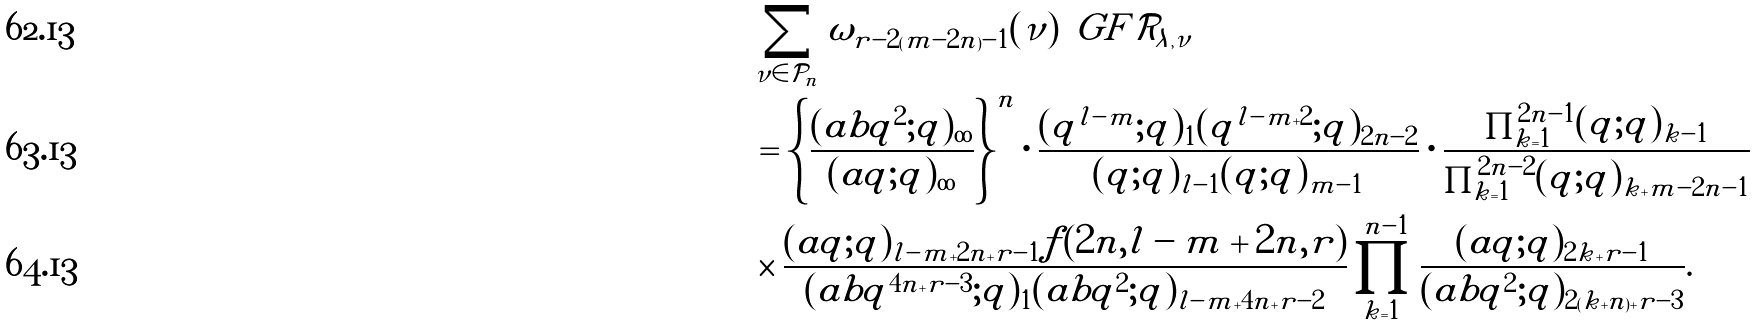<formula> <loc_0><loc_0><loc_500><loc_500>& \sum _ { \nu \in \mathcal { P } _ { n } } \omega _ { r - 2 ( m - 2 n ) - 1 } ( \nu ) \, \ G F { \mathcal { R } _ { \lambda , \nu } } \\ & = \left \{ \frac { ( a b q ^ { 2 } ; q ) _ { \infty } } { ( a q ; q ) _ { \infty } } \right \} ^ { n } \cdot \frac { ( q ^ { l - m } ; q ) _ { 1 } ( q ^ { l - m + 2 } ; q ) _ { 2 n - 2 } } { ( q ; q ) _ { l - 1 } ( q ; q ) _ { m - 1 } } \cdot \frac { \prod _ { k = 1 } ^ { 2 n - 1 } ( q ; q ) _ { k - 1 } } { \prod _ { k = 1 } ^ { 2 n - 2 } ( q ; q ) _ { k + m - 2 n - 1 } } \\ & \times \frac { ( a q ; q ) _ { l - m + 2 n + r - 1 } f ( 2 n , l - m + 2 n , r ) } { ( a b q ^ { 4 n + r - 3 } ; q ) _ { 1 } ( a b q ^ { 2 } ; q ) _ { l - m + 4 n + r - 2 } } \prod _ { k = 1 } ^ { n - 1 } \frac { ( a q ; q ) _ { 2 k + r - 1 } } { ( a b q ^ { 2 } ; q ) _ { 2 ( k + n ) + r - 3 } } .</formula> 